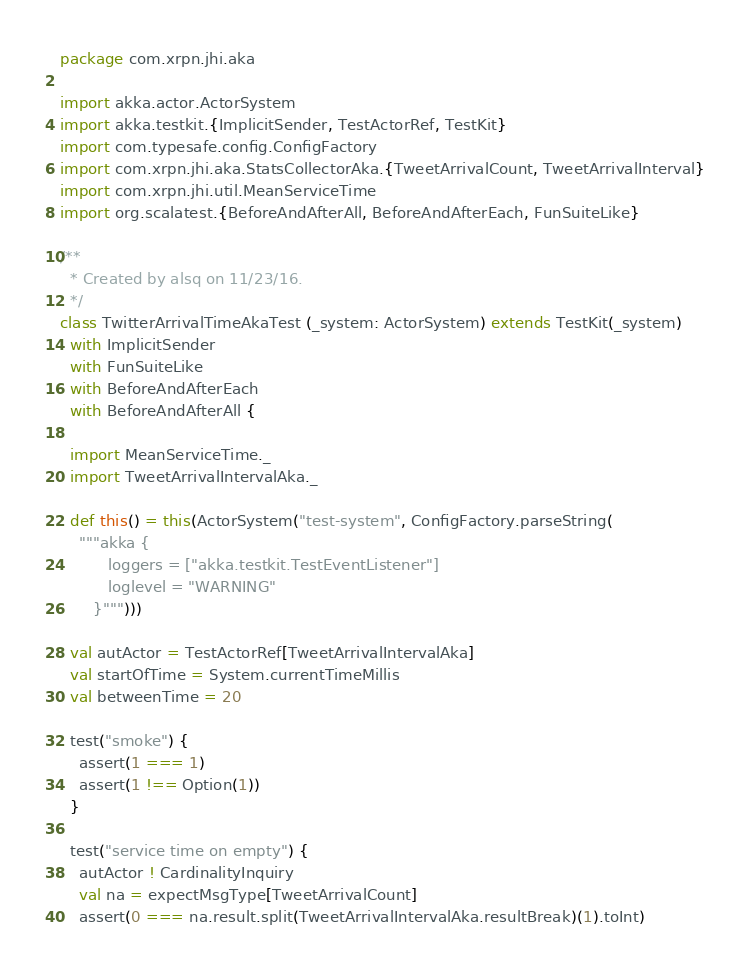Convert code to text. <code><loc_0><loc_0><loc_500><loc_500><_Scala_>package com.xrpn.jhi.aka

import akka.actor.ActorSystem
import akka.testkit.{ImplicitSender, TestActorRef, TestKit}
import com.typesafe.config.ConfigFactory
import com.xrpn.jhi.aka.StatsCollectorAka.{TweetArrivalCount, TweetArrivalInterval}
import com.xrpn.jhi.util.MeanServiceTime
import org.scalatest.{BeforeAndAfterAll, BeforeAndAfterEach, FunSuiteLike}

/**
  * Created by alsq on 11/23/16.
  */
class TwitterArrivalTimeAkaTest (_system: ActorSystem) extends TestKit(_system)
  with ImplicitSender
  with FunSuiteLike
  with BeforeAndAfterEach
  with BeforeAndAfterAll {

  import MeanServiceTime._
  import TweetArrivalIntervalAka._

  def this() = this(ActorSystem("test-system", ConfigFactory.parseString(
    """akka {
          loggers = ["akka.testkit.TestEventListener"]
          loglevel = "WARNING"
       }""")))

  val autActor = TestActorRef[TweetArrivalIntervalAka]
  val startOfTime = System.currentTimeMillis
  val betweenTime = 20

  test("smoke") {
    assert(1 === 1)
    assert(1 !== Option(1))
  }

  test("service time on empty") {
    autActor ! CardinalityInquiry
    val na = expectMsgType[TweetArrivalCount]
    assert(0 === na.result.split(TweetArrivalIntervalAka.resultBreak)(1).toInt)</code> 